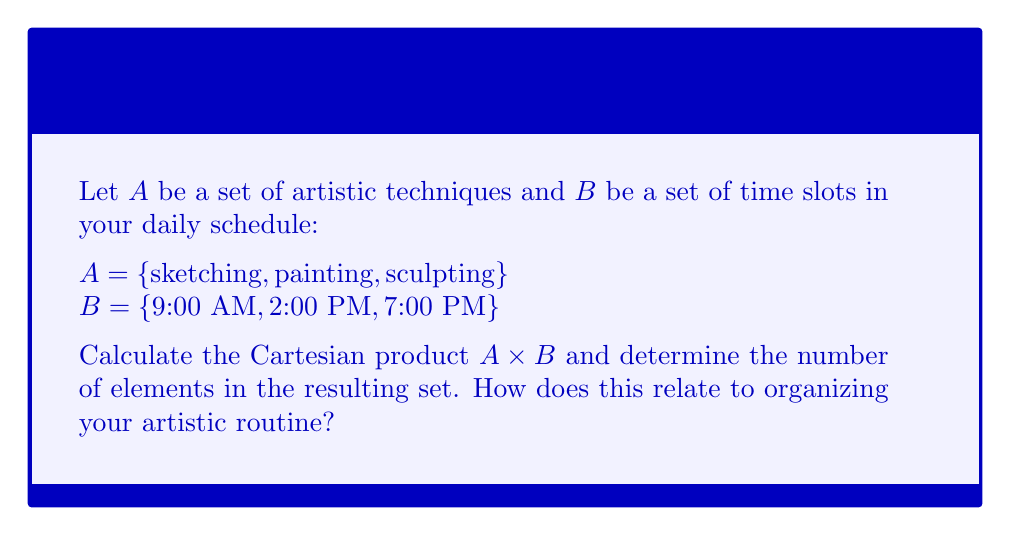Provide a solution to this math problem. To solve this problem, we'll follow these steps:

1) Recall that the Cartesian product of two sets A and B, denoted A × B, is the set of all ordered pairs (a, b) where a ∈ A and b ∈ B.

2) Let's list out all the ordered pairs in A × B:

   A × B = {(sketching, 9:00 AM), (sketching, 2:00 PM), (sketching, 7:00 PM),
            (painting, 9:00 AM), (painting, 2:00 PM), (painting, 7:00 PM),
            (sculpting, 9:00 AM), (sculpting, 2:00 PM), (sculpting, 7:00 PM)}

3) To count the number of elements in A × B, we can use the multiplication principle:

   $|A \times B| = |A| \cdot |B|$

   Where $|A|$ represents the number of elements in set A, and $|B|$ represents the number of elements in set B.

4) In this case:
   $|A| = 3$ (sketching, painting, sculpting)
   $|B| = 3$ (9:00 AM, 2:00 PM, 7:00 PM)

5) Therefore:
   $|A \times B| = 3 \cdot 3 = 9$

This result relates to organizing an artistic routine by providing all possible combinations of artistic techniques and time slots. Each pair represents a potential scheduled activity, allowing for a structured approach to planning daily artistic practices.
Answer: The Cartesian product A × B contains 9 elements. This provides 9 different options for scheduling artistic activities throughout the day, supporting a structured and predictable artistic routine. 